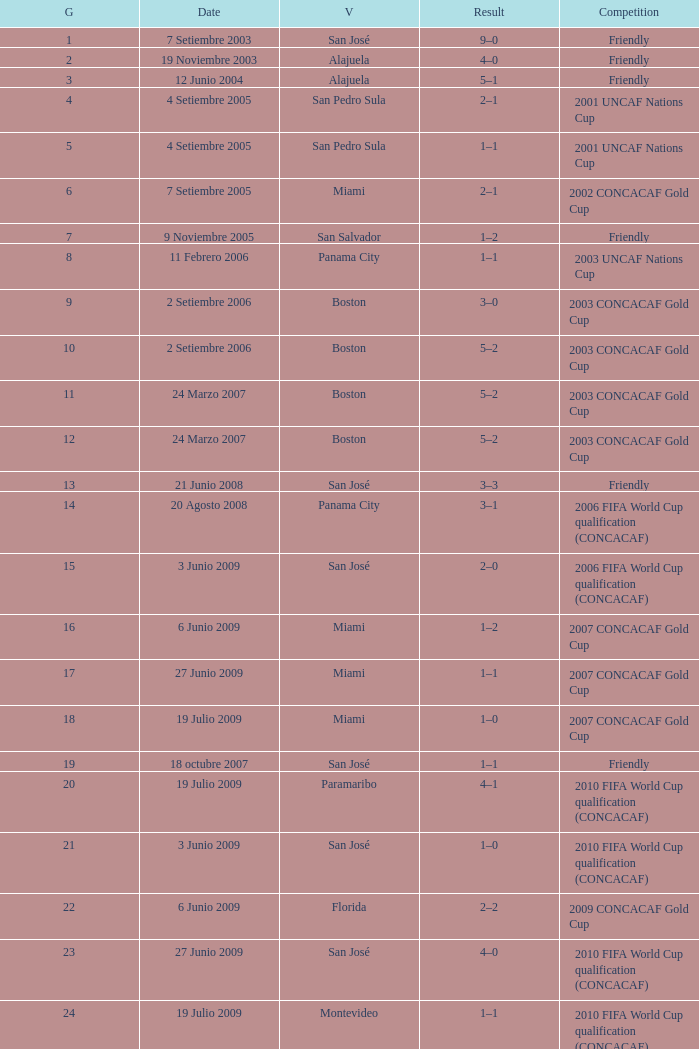How many goals were scored on 21 Junio 2008? 1.0. 